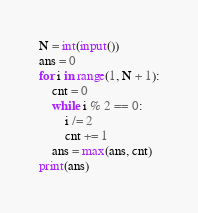Convert code to text. <code><loc_0><loc_0><loc_500><loc_500><_Python_>N = int(input())
ans = 0
for i in range(1, N + 1):
    cnt = 0
    while i % 2 == 0:
        i /= 2
        cnt += 1
    ans = max(ans, cnt)
print(ans)</code> 